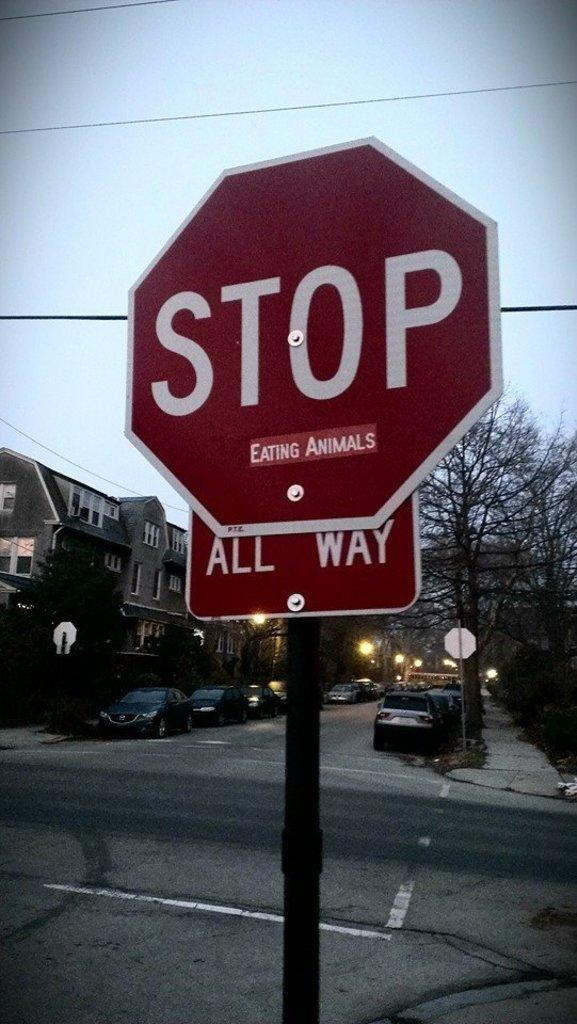<image>
Present a compact description of the photo's key features. On a stop sign, in small letters under the word stop, and above the all way sign, it says eating animals. 